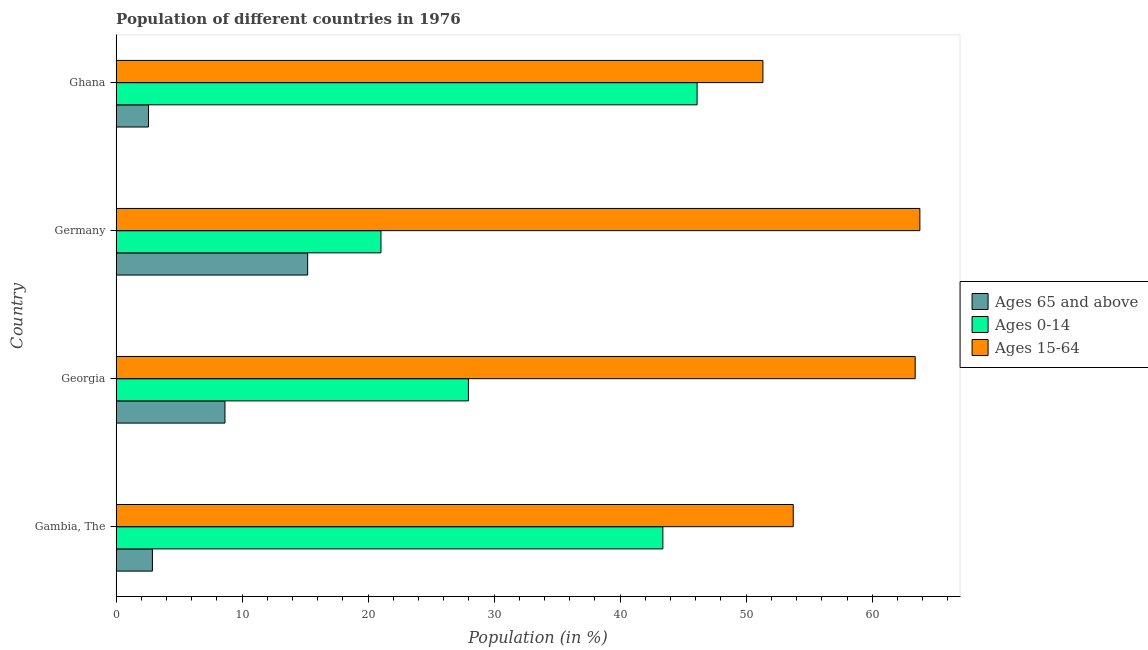How many groups of bars are there?
Give a very brief answer. 4. Are the number of bars per tick equal to the number of legend labels?
Offer a very short reply. Yes. Are the number of bars on each tick of the Y-axis equal?
Offer a very short reply. Yes. How many bars are there on the 1st tick from the top?
Provide a succinct answer. 3. What is the label of the 4th group of bars from the top?
Give a very brief answer. Gambia, The. In how many cases, is the number of bars for a given country not equal to the number of legend labels?
Provide a short and direct response. 0. What is the percentage of population within the age-group 0-14 in Ghana?
Your answer should be compact. 46.11. Across all countries, what is the maximum percentage of population within the age-group 0-14?
Give a very brief answer. 46.11. Across all countries, what is the minimum percentage of population within the age-group 15-64?
Keep it short and to the point. 51.33. In which country was the percentage of population within the age-group of 65 and above maximum?
Provide a succinct answer. Germany. What is the total percentage of population within the age-group 15-64 in the graph?
Make the answer very short. 232.26. What is the difference between the percentage of population within the age-group 15-64 in Georgia and that in Germany?
Offer a terse response. -0.37. What is the difference between the percentage of population within the age-group 0-14 in Ghana and the percentage of population within the age-group 15-64 in Georgia?
Provide a succinct answer. -17.31. What is the average percentage of population within the age-group 0-14 per country?
Make the answer very short. 34.62. What is the difference between the percentage of population within the age-group of 65 and above and percentage of population within the age-group 15-64 in Gambia, The?
Give a very brief answer. -50.86. In how many countries, is the percentage of population within the age-group of 65 and above greater than 58 %?
Ensure brevity in your answer.  0. What is the ratio of the percentage of population within the age-group of 65 and above in Georgia to that in Germany?
Offer a terse response. 0.57. Is the percentage of population within the age-group of 65 and above in Georgia less than that in Germany?
Give a very brief answer. Yes. Is the difference between the percentage of population within the age-group 0-14 in Gambia, The and Germany greater than the difference between the percentage of population within the age-group 15-64 in Gambia, The and Germany?
Offer a very short reply. Yes. What is the difference between the highest and the second highest percentage of population within the age-group 0-14?
Offer a very short reply. 2.72. What is the difference between the highest and the lowest percentage of population within the age-group of 65 and above?
Give a very brief answer. 12.63. What does the 1st bar from the top in Gambia, The represents?
Your response must be concise. Ages 15-64. What does the 3rd bar from the bottom in Gambia, The represents?
Make the answer very short. Ages 15-64. Are the values on the major ticks of X-axis written in scientific E-notation?
Offer a terse response. No. Does the graph contain any zero values?
Give a very brief answer. No. Does the graph contain grids?
Offer a very short reply. No. Where does the legend appear in the graph?
Provide a succinct answer. Center right. How are the legend labels stacked?
Offer a very short reply. Vertical. What is the title of the graph?
Ensure brevity in your answer.  Population of different countries in 1976. Does "Liquid fuel" appear as one of the legend labels in the graph?
Provide a succinct answer. No. What is the Population (in %) in Ages 65 and above in Gambia, The?
Offer a terse response. 2.88. What is the Population (in %) of Ages 0-14 in Gambia, The?
Provide a succinct answer. 43.39. What is the Population (in %) of Ages 15-64 in Gambia, The?
Your response must be concise. 53.73. What is the Population (in %) in Ages 65 and above in Georgia?
Your answer should be very brief. 8.64. What is the Population (in %) of Ages 0-14 in Georgia?
Offer a very short reply. 27.95. What is the Population (in %) of Ages 15-64 in Georgia?
Ensure brevity in your answer.  63.41. What is the Population (in %) of Ages 65 and above in Germany?
Keep it short and to the point. 15.2. What is the Population (in %) in Ages 0-14 in Germany?
Your answer should be compact. 21.02. What is the Population (in %) of Ages 15-64 in Germany?
Make the answer very short. 63.78. What is the Population (in %) of Ages 65 and above in Ghana?
Keep it short and to the point. 2.57. What is the Population (in %) of Ages 0-14 in Ghana?
Give a very brief answer. 46.11. What is the Population (in %) in Ages 15-64 in Ghana?
Offer a terse response. 51.33. Across all countries, what is the maximum Population (in %) of Ages 65 and above?
Provide a short and direct response. 15.2. Across all countries, what is the maximum Population (in %) in Ages 0-14?
Ensure brevity in your answer.  46.11. Across all countries, what is the maximum Population (in %) in Ages 15-64?
Give a very brief answer. 63.78. Across all countries, what is the minimum Population (in %) in Ages 65 and above?
Offer a terse response. 2.57. Across all countries, what is the minimum Population (in %) of Ages 0-14?
Your response must be concise. 21.02. Across all countries, what is the minimum Population (in %) of Ages 15-64?
Your answer should be very brief. 51.33. What is the total Population (in %) of Ages 65 and above in the graph?
Make the answer very short. 29.28. What is the total Population (in %) in Ages 0-14 in the graph?
Keep it short and to the point. 138.46. What is the total Population (in %) of Ages 15-64 in the graph?
Your answer should be compact. 232.26. What is the difference between the Population (in %) of Ages 65 and above in Gambia, The and that in Georgia?
Keep it short and to the point. -5.76. What is the difference between the Population (in %) of Ages 0-14 in Gambia, The and that in Georgia?
Offer a very short reply. 15.43. What is the difference between the Population (in %) in Ages 15-64 in Gambia, The and that in Georgia?
Your answer should be compact. -9.68. What is the difference between the Population (in %) in Ages 65 and above in Gambia, The and that in Germany?
Offer a terse response. -12.32. What is the difference between the Population (in %) in Ages 0-14 in Gambia, The and that in Germany?
Give a very brief answer. 22.37. What is the difference between the Population (in %) in Ages 15-64 in Gambia, The and that in Germany?
Your response must be concise. -10.05. What is the difference between the Population (in %) in Ages 65 and above in Gambia, The and that in Ghana?
Provide a succinct answer. 0.31. What is the difference between the Population (in %) of Ages 0-14 in Gambia, The and that in Ghana?
Provide a succinct answer. -2.72. What is the difference between the Population (in %) of Ages 15-64 in Gambia, The and that in Ghana?
Offer a very short reply. 2.41. What is the difference between the Population (in %) of Ages 65 and above in Georgia and that in Germany?
Your response must be concise. -6.56. What is the difference between the Population (in %) of Ages 0-14 in Georgia and that in Germany?
Give a very brief answer. 6.94. What is the difference between the Population (in %) in Ages 15-64 in Georgia and that in Germany?
Make the answer very short. -0.37. What is the difference between the Population (in %) of Ages 65 and above in Georgia and that in Ghana?
Your response must be concise. 6.07. What is the difference between the Population (in %) in Ages 0-14 in Georgia and that in Ghana?
Your answer should be compact. -18.15. What is the difference between the Population (in %) of Ages 15-64 in Georgia and that in Ghana?
Provide a succinct answer. 12.08. What is the difference between the Population (in %) in Ages 65 and above in Germany and that in Ghana?
Your answer should be compact. 12.63. What is the difference between the Population (in %) of Ages 0-14 in Germany and that in Ghana?
Offer a terse response. -25.09. What is the difference between the Population (in %) in Ages 15-64 in Germany and that in Ghana?
Make the answer very short. 12.46. What is the difference between the Population (in %) in Ages 65 and above in Gambia, The and the Population (in %) in Ages 0-14 in Georgia?
Your response must be concise. -25.08. What is the difference between the Population (in %) in Ages 65 and above in Gambia, The and the Population (in %) in Ages 15-64 in Georgia?
Ensure brevity in your answer.  -60.53. What is the difference between the Population (in %) in Ages 0-14 in Gambia, The and the Population (in %) in Ages 15-64 in Georgia?
Give a very brief answer. -20.02. What is the difference between the Population (in %) in Ages 65 and above in Gambia, The and the Population (in %) in Ages 0-14 in Germany?
Provide a short and direct response. -18.14. What is the difference between the Population (in %) of Ages 65 and above in Gambia, The and the Population (in %) of Ages 15-64 in Germany?
Ensure brevity in your answer.  -60.9. What is the difference between the Population (in %) in Ages 0-14 in Gambia, The and the Population (in %) in Ages 15-64 in Germany?
Ensure brevity in your answer.  -20.4. What is the difference between the Population (in %) in Ages 65 and above in Gambia, The and the Population (in %) in Ages 0-14 in Ghana?
Your answer should be very brief. -43.23. What is the difference between the Population (in %) in Ages 65 and above in Gambia, The and the Population (in %) in Ages 15-64 in Ghana?
Offer a terse response. -48.45. What is the difference between the Population (in %) in Ages 0-14 in Gambia, The and the Population (in %) in Ages 15-64 in Ghana?
Provide a succinct answer. -7.94. What is the difference between the Population (in %) of Ages 65 and above in Georgia and the Population (in %) of Ages 0-14 in Germany?
Give a very brief answer. -12.38. What is the difference between the Population (in %) in Ages 65 and above in Georgia and the Population (in %) in Ages 15-64 in Germany?
Your answer should be compact. -55.15. What is the difference between the Population (in %) of Ages 0-14 in Georgia and the Population (in %) of Ages 15-64 in Germany?
Provide a short and direct response. -35.83. What is the difference between the Population (in %) in Ages 65 and above in Georgia and the Population (in %) in Ages 0-14 in Ghana?
Give a very brief answer. -37.47. What is the difference between the Population (in %) in Ages 65 and above in Georgia and the Population (in %) in Ages 15-64 in Ghana?
Ensure brevity in your answer.  -42.69. What is the difference between the Population (in %) of Ages 0-14 in Georgia and the Population (in %) of Ages 15-64 in Ghana?
Offer a terse response. -23.37. What is the difference between the Population (in %) in Ages 65 and above in Germany and the Population (in %) in Ages 0-14 in Ghana?
Offer a very short reply. -30.91. What is the difference between the Population (in %) of Ages 65 and above in Germany and the Population (in %) of Ages 15-64 in Ghana?
Keep it short and to the point. -36.13. What is the difference between the Population (in %) in Ages 0-14 in Germany and the Population (in %) in Ages 15-64 in Ghana?
Your response must be concise. -30.31. What is the average Population (in %) of Ages 65 and above per country?
Make the answer very short. 7.32. What is the average Population (in %) of Ages 0-14 per country?
Your answer should be compact. 34.62. What is the average Population (in %) in Ages 15-64 per country?
Provide a succinct answer. 58.06. What is the difference between the Population (in %) in Ages 65 and above and Population (in %) in Ages 0-14 in Gambia, The?
Offer a terse response. -40.51. What is the difference between the Population (in %) of Ages 65 and above and Population (in %) of Ages 15-64 in Gambia, The?
Your answer should be very brief. -50.86. What is the difference between the Population (in %) in Ages 0-14 and Population (in %) in Ages 15-64 in Gambia, The?
Your answer should be very brief. -10.35. What is the difference between the Population (in %) of Ages 65 and above and Population (in %) of Ages 0-14 in Georgia?
Offer a terse response. -19.32. What is the difference between the Population (in %) in Ages 65 and above and Population (in %) in Ages 15-64 in Georgia?
Give a very brief answer. -54.77. What is the difference between the Population (in %) of Ages 0-14 and Population (in %) of Ages 15-64 in Georgia?
Provide a succinct answer. -35.46. What is the difference between the Population (in %) of Ages 65 and above and Population (in %) of Ages 0-14 in Germany?
Ensure brevity in your answer.  -5.82. What is the difference between the Population (in %) in Ages 65 and above and Population (in %) in Ages 15-64 in Germany?
Provide a succinct answer. -48.58. What is the difference between the Population (in %) in Ages 0-14 and Population (in %) in Ages 15-64 in Germany?
Your response must be concise. -42.77. What is the difference between the Population (in %) of Ages 65 and above and Population (in %) of Ages 0-14 in Ghana?
Provide a succinct answer. -43.54. What is the difference between the Population (in %) in Ages 65 and above and Population (in %) in Ages 15-64 in Ghana?
Ensure brevity in your answer.  -48.76. What is the difference between the Population (in %) in Ages 0-14 and Population (in %) in Ages 15-64 in Ghana?
Offer a very short reply. -5.22. What is the ratio of the Population (in %) of Ages 65 and above in Gambia, The to that in Georgia?
Keep it short and to the point. 0.33. What is the ratio of the Population (in %) in Ages 0-14 in Gambia, The to that in Georgia?
Your answer should be compact. 1.55. What is the ratio of the Population (in %) in Ages 15-64 in Gambia, The to that in Georgia?
Offer a terse response. 0.85. What is the ratio of the Population (in %) in Ages 65 and above in Gambia, The to that in Germany?
Provide a succinct answer. 0.19. What is the ratio of the Population (in %) in Ages 0-14 in Gambia, The to that in Germany?
Keep it short and to the point. 2.06. What is the ratio of the Population (in %) in Ages 15-64 in Gambia, The to that in Germany?
Your answer should be compact. 0.84. What is the ratio of the Population (in %) in Ages 65 and above in Gambia, The to that in Ghana?
Offer a terse response. 1.12. What is the ratio of the Population (in %) in Ages 0-14 in Gambia, The to that in Ghana?
Provide a short and direct response. 0.94. What is the ratio of the Population (in %) in Ages 15-64 in Gambia, The to that in Ghana?
Ensure brevity in your answer.  1.05. What is the ratio of the Population (in %) of Ages 65 and above in Georgia to that in Germany?
Give a very brief answer. 0.57. What is the ratio of the Population (in %) in Ages 0-14 in Georgia to that in Germany?
Provide a succinct answer. 1.33. What is the ratio of the Population (in %) in Ages 15-64 in Georgia to that in Germany?
Your answer should be very brief. 0.99. What is the ratio of the Population (in %) in Ages 65 and above in Georgia to that in Ghana?
Provide a short and direct response. 3.36. What is the ratio of the Population (in %) in Ages 0-14 in Georgia to that in Ghana?
Your response must be concise. 0.61. What is the ratio of the Population (in %) in Ages 15-64 in Georgia to that in Ghana?
Offer a very short reply. 1.24. What is the ratio of the Population (in %) in Ages 65 and above in Germany to that in Ghana?
Ensure brevity in your answer.  5.92. What is the ratio of the Population (in %) in Ages 0-14 in Germany to that in Ghana?
Your response must be concise. 0.46. What is the ratio of the Population (in %) of Ages 15-64 in Germany to that in Ghana?
Keep it short and to the point. 1.24. What is the difference between the highest and the second highest Population (in %) in Ages 65 and above?
Your response must be concise. 6.56. What is the difference between the highest and the second highest Population (in %) in Ages 0-14?
Give a very brief answer. 2.72. What is the difference between the highest and the second highest Population (in %) in Ages 15-64?
Provide a succinct answer. 0.37. What is the difference between the highest and the lowest Population (in %) of Ages 65 and above?
Your answer should be compact. 12.63. What is the difference between the highest and the lowest Population (in %) of Ages 0-14?
Offer a very short reply. 25.09. What is the difference between the highest and the lowest Population (in %) in Ages 15-64?
Your answer should be compact. 12.46. 